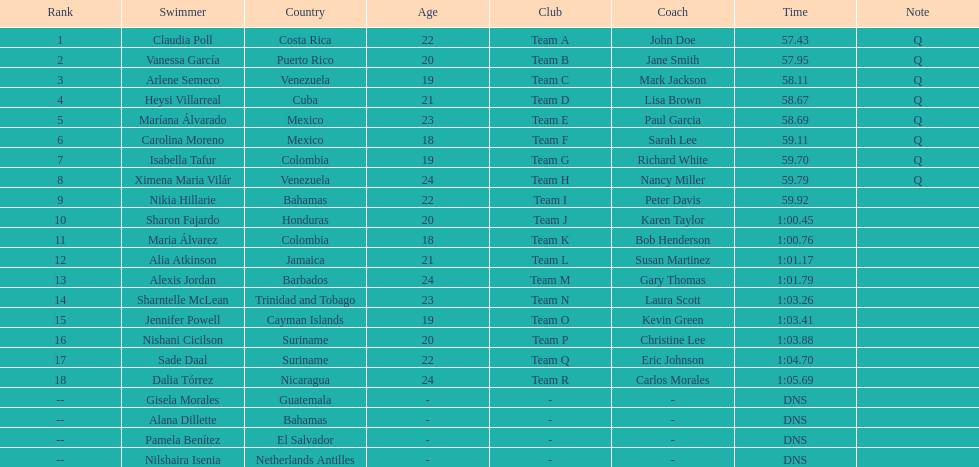How many competitors from venezuela qualified for the final? 2. 